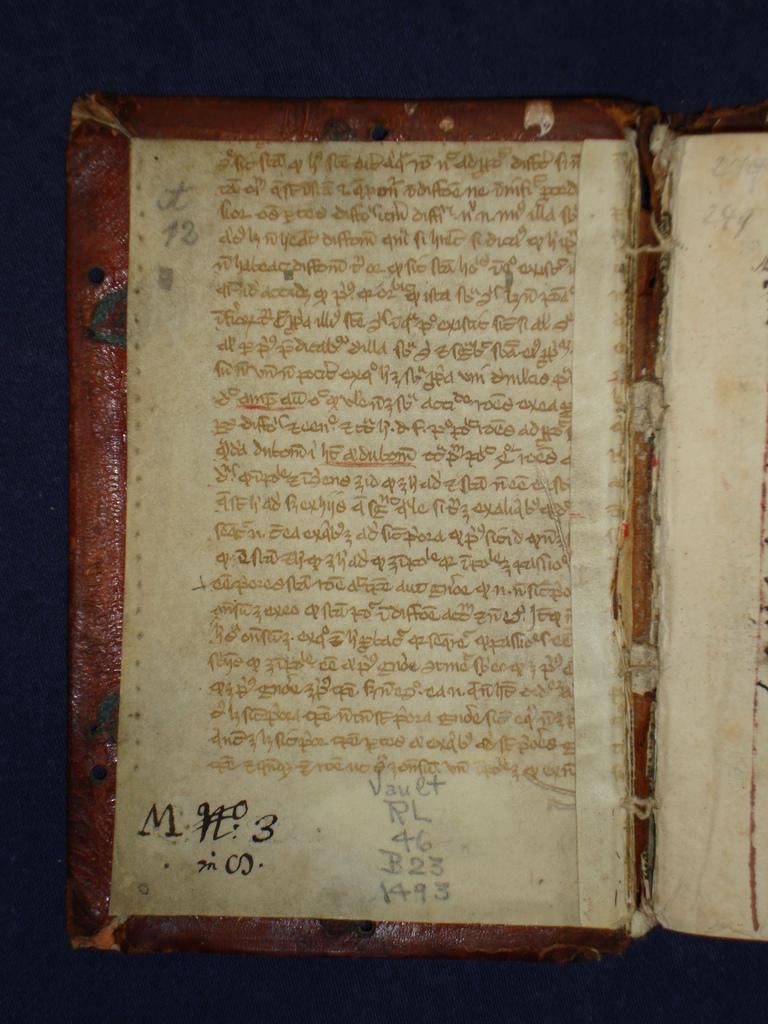What is the main object in the image? There is a book in the image. What is placed on the book? There are papers on the book. Can you describe the content of the book or papers? There are words written on the book or papers. Are there any numerical elements in the image? Yes, there are numbers visible in the image. How would you describe the lighting in the image? The background of the image is slightly dark. Is there a cave in the background of the image? No, there is no cave present in the image. Can you see any quicksand in the image? No, there is no quicksand present in the image. 